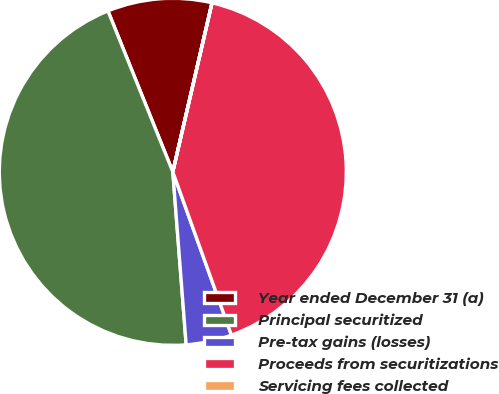Convert chart. <chart><loc_0><loc_0><loc_500><loc_500><pie_chart><fcel>Year ended December 31 (a)<fcel>Principal securitized<fcel>Pre-tax gains (losses)<fcel>Proceeds from securitizations<fcel>Servicing fees collected<nl><fcel>9.72%<fcel>45.13%<fcel>4.26%<fcel>40.88%<fcel>0.01%<nl></chart> 